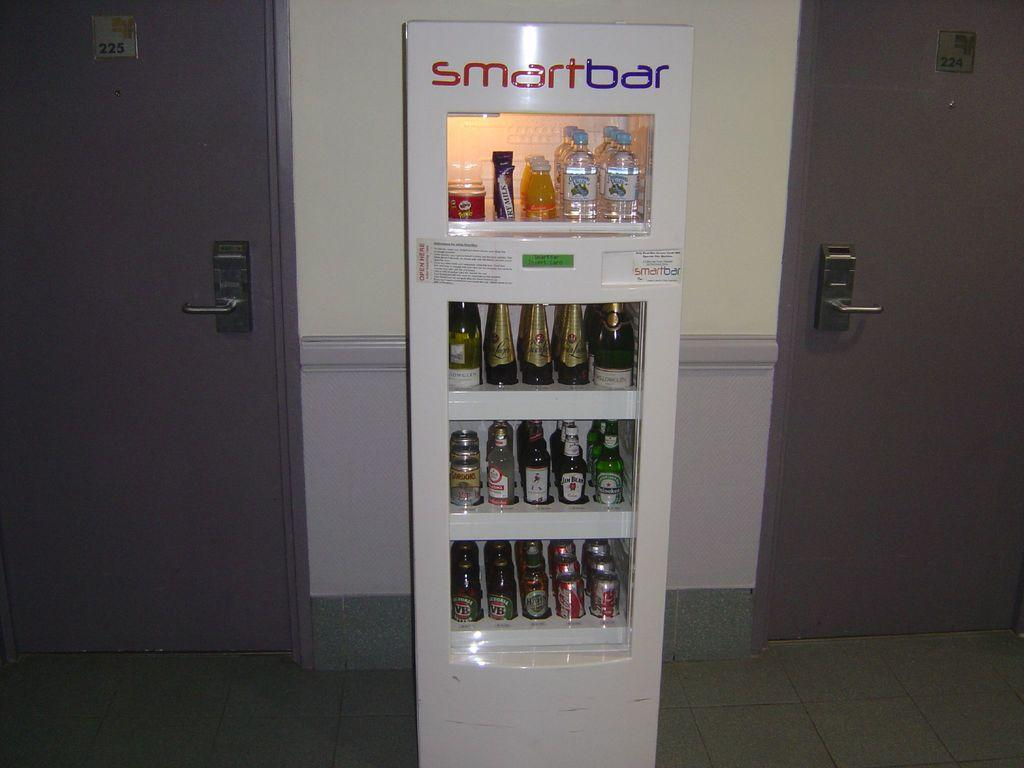<image>
Share a concise interpretation of the image provided. A Smart Bar vending machine has many beverages inside. 